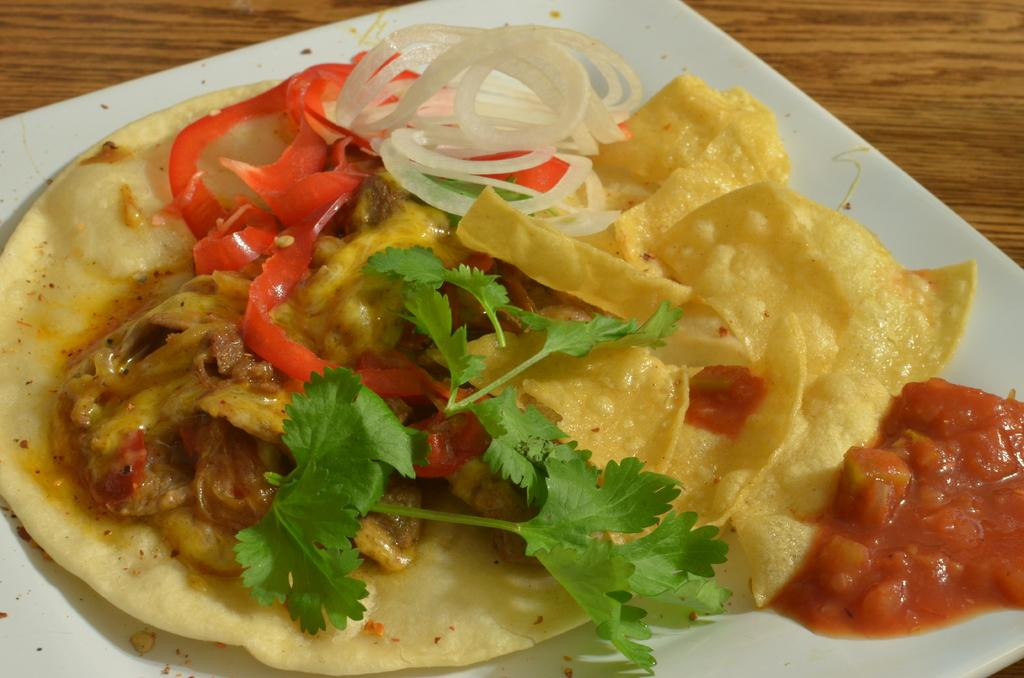What is on the plate that is visible in the image? There is a plate with food in the image. What type of surface is the plate resting on? The wooden object in the image resembles a table. What color is the beetle crawling on the food in the image? There is no beetle present in the image; it only features a plate with food and a wooden object that resembles a table. 